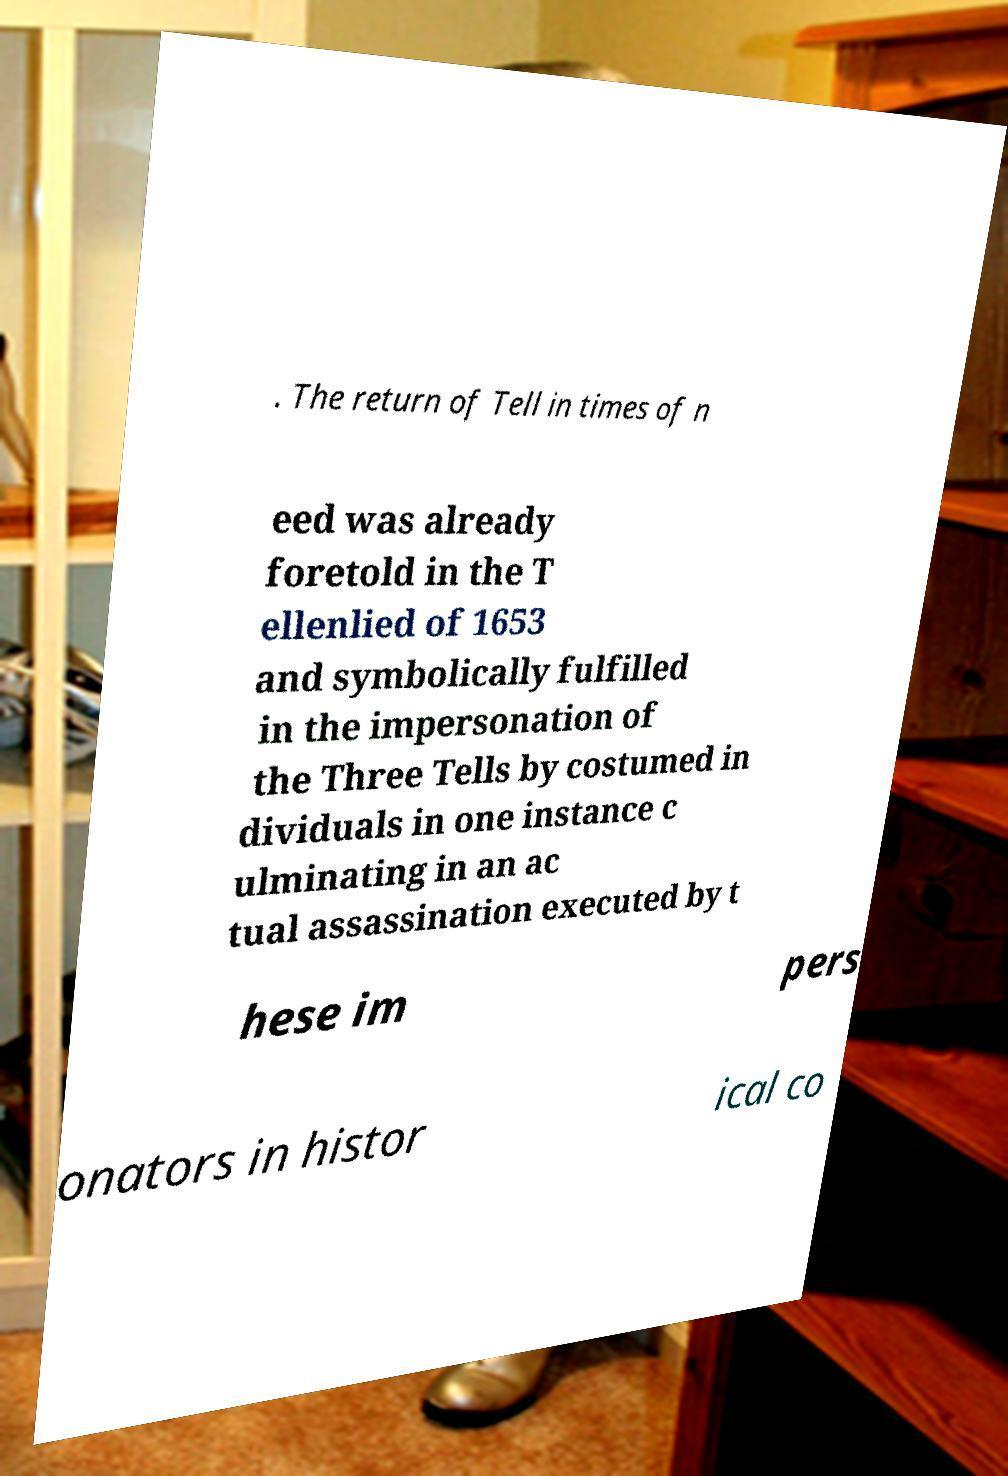For documentation purposes, I need the text within this image transcribed. Could you provide that? . The return of Tell in times of n eed was already foretold in the T ellenlied of 1653 and symbolically fulfilled in the impersonation of the Three Tells by costumed in dividuals in one instance c ulminating in an ac tual assassination executed by t hese im pers onators in histor ical co 